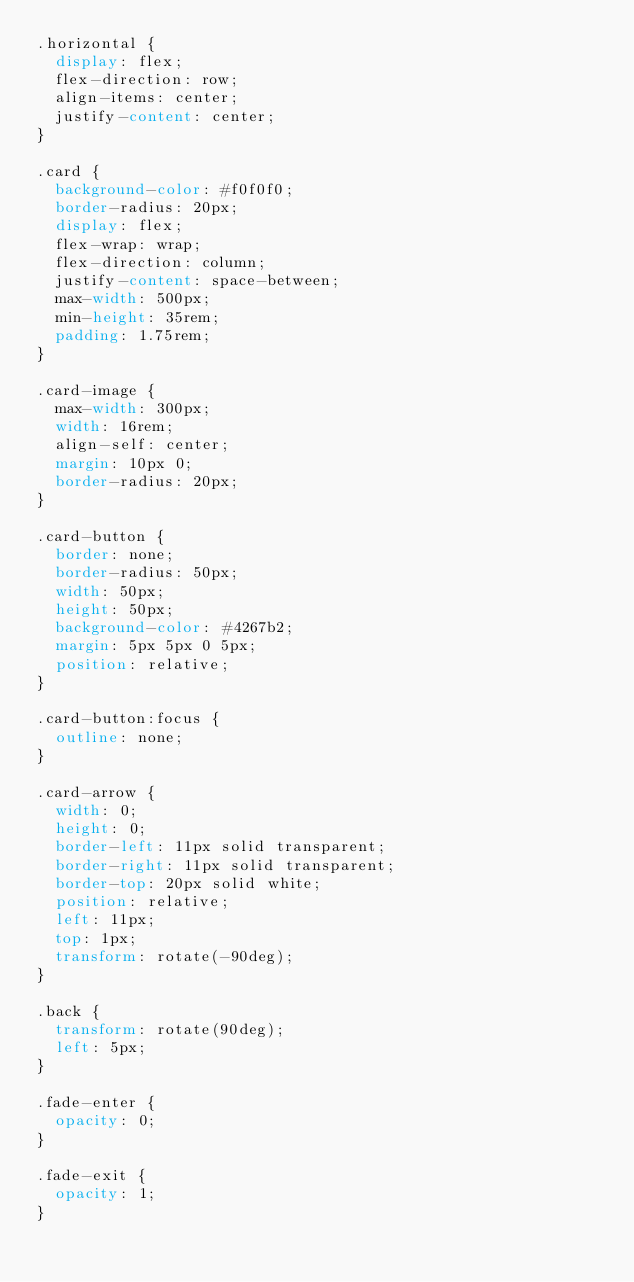<code> <loc_0><loc_0><loc_500><loc_500><_CSS_>.horizontal {
  display: flex;
  flex-direction: row;
  align-items: center;
  justify-content: center;
}

.card {
  background-color: #f0f0f0;
  border-radius: 20px;
  display: flex;
  flex-wrap: wrap;
  flex-direction: column;
  justify-content: space-between;
  max-width: 500px;
  min-height: 35rem;
  padding: 1.75rem;
}

.card-image {
  max-width: 300px;
  width: 16rem;
  align-self: center;
  margin: 10px 0;
  border-radius: 20px;
}

.card-button {
  border: none;
  border-radius: 50px;
  width: 50px;
  height: 50px;
  background-color: #4267b2;
  margin: 5px 5px 0 5px;
  position: relative;
}

.card-button:focus {
  outline: none;
}

.card-arrow {
  width: 0;
  height: 0;
  border-left: 11px solid transparent;
  border-right: 11px solid transparent;
  border-top: 20px solid white;
  position: relative;
  left: 11px;
  top: 1px;
  transform: rotate(-90deg);
}

.back {
  transform: rotate(90deg);
  left: 5px;
}

.fade-enter {
  opacity: 0;
}

.fade-exit {
  opacity: 1;
}
</code> 